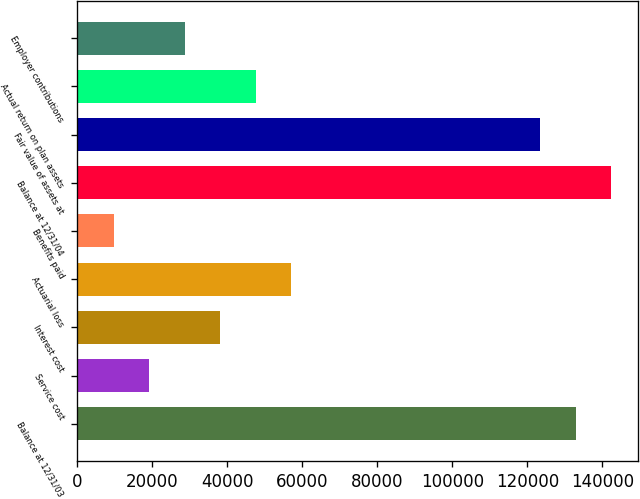Convert chart to OTSL. <chart><loc_0><loc_0><loc_500><loc_500><bar_chart><fcel>Balance at 12/31/03<fcel>Service cost<fcel>Interest cost<fcel>Actuarial loss<fcel>Benefits paid<fcel>Balance at 12/31/04<fcel>Fair value of assets at<fcel>Actual return on plan assets<fcel>Employer contributions<nl><fcel>132884<fcel>19228.6<fcel>38171.2<fcel>57113.8<fcel>9757.3<fcel>142356<fcel>123413<fcel>47642.5<fcel>28699.9<nl></chart> 